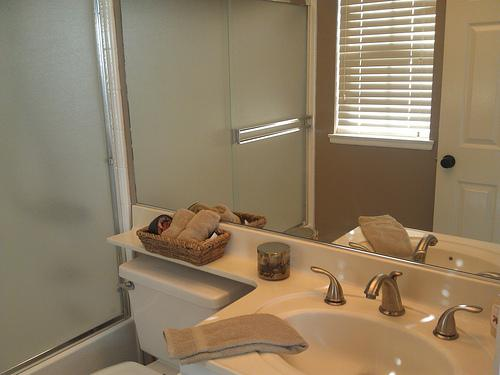Mention three items found in the image related to hygiene and decor, and explain their purpose. The white sink, for washing hands and face; the white toilet, for personal hygiene; and the frosted glass shower, for a private and elegant bathing experience. Describe the atmosphere created by the design and arrangement of elements in the image. The bathroom appears tidy and well-organized, with modern fixtures and furnishings, creating a calm and inviting atmosphere. Express the main elements within the image in a poetic manner. In a serene retreat, a mirror vast reflects the bathroom's form, while water pours from steel embrace, and window blinds adorn. Select three objects in the image and describe them in detail. The large mirror spans the bathroom wall, reflecting the entire interior; the white, oval-shaped sink has a brushed steel faucet and steel fixtures; and the rectangular wicker basket, placed above the toilet, contains taupe towels. Enumerate the objects found in the image related to the sink and toilet. Sink, faucet, oval-shaped sink, steel fixtures, grey hand towel, taupe hand towel, white toilet, silver lever, wicker basket with towels. Mention the key elements of the bathroom shown in the image. The bathroom comprises of a large mirror, a sink with a silver faucet, a toilet, a shower with smoked glass door, a small window with blinds, and a rectangular wicker basket with towels. Provide a brief overview of the main features of the image. The image features a large bathroom mirror, a white sink with a steel faucet, a white toilet with a silver lever, a frosted glass shower, a window with blinds, and a wicker basket with towels. Imagine you are giving someone a tour of the bathroom in the image. What would you say? This bathroom has a stylish design with a large mirror, a modern sink and faucet, a clean white toilet, a frosted glass shower, a window with blinds, and a beautifully placed wicker basket with towels. Write a sentence describing the most prominent feature of the bathroom. The large bathroom mirror spans the wall, reflecting the interior with a sink, a toilet, a shower, and a window. Describe the elements present around the sink area in the image. Around the sink area, there is a brushed steel faucet, a grey hand towel, a white oval-shaped sink, a taupe hand towel on the sink, a brown basket with towels, and steel fixtures. 